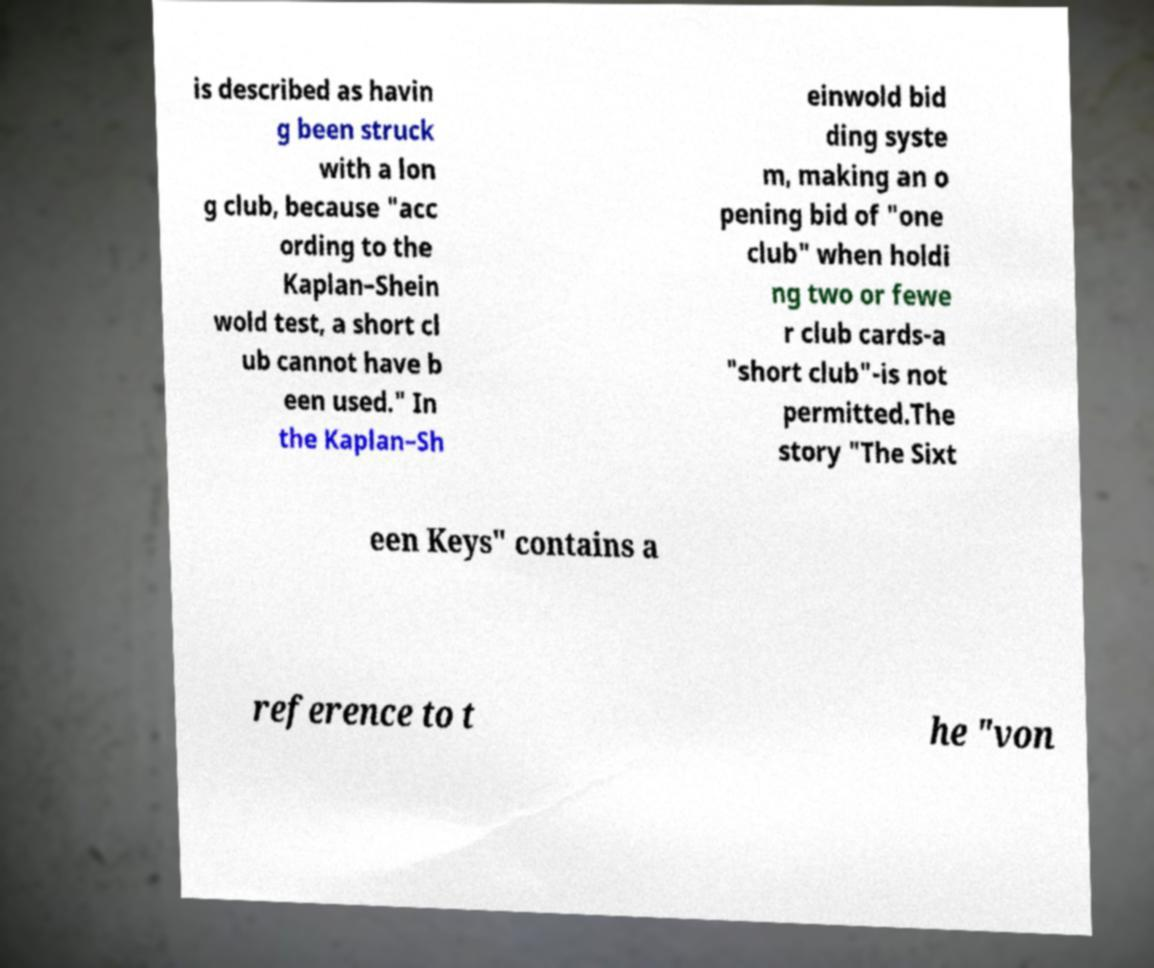Can you read and provide the text displayed in the image?This photo seems to have some interesting text. Can you extract and type it out for me? is described as havin g been struck with a lon g club, because "acc ording to the Kaplan–Shein wold test, a short cl ub cannot have b een used." In the Kaplan–Sh einwold bid ding syste m, making an o pening bid of "one club" when holdi ng two or fewe r club cards-a "short club"-is not permitted.The story "The Sixt een Keys" contains a reference to t he "von 